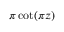<formula> <loc_0><loc_0><loc_500><loc_500>\pi \cot ( \pi z )</formula> 